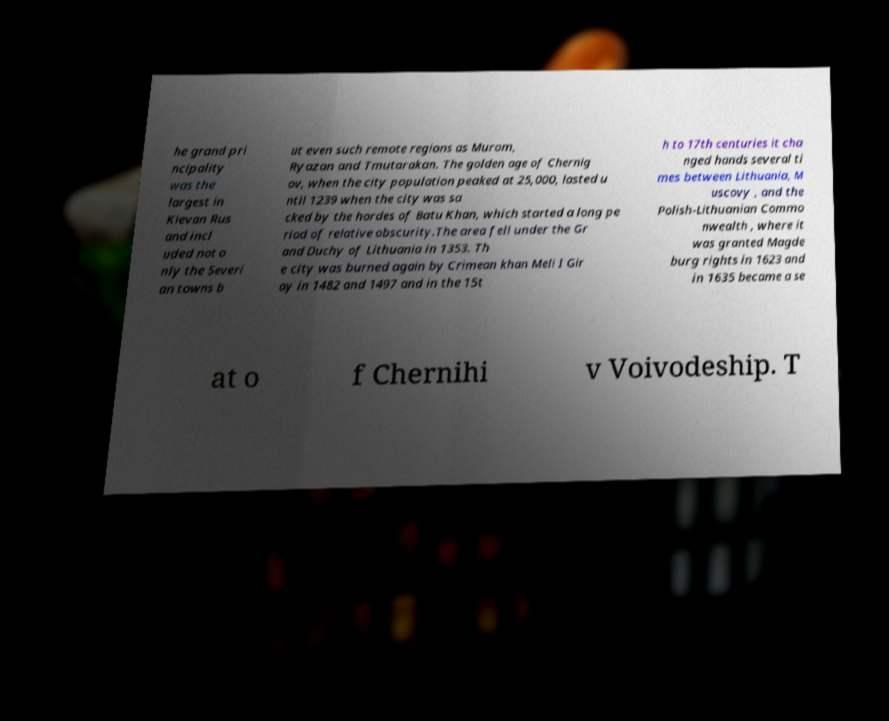Could you extract and type out the text from this image? he grand pri ncipality was the largest in Kievan Rus and incl uded not o nly the Severi an towns b ut even such remote regions as Murom, Ryazan and Tmutarakan. The golden age of Chernig ov, when the city population peaked at 25,000, lasted u ntil 1239 when the city was sa cked by the hordes of Batu Khan, which started a long pe riod of relative obscurity.The area fell under the Gr and Duchy of Lithuania in 1353. Th e city was burned again by Crimean khan Meli I Gir ay in 1482 and 1497 and in the 15t h to 17th centuries it cha nged hands several ti mes between Lithuania, M uscovy , and the Polish-Lithuanian Commo nwealth , where it was granted Magde burg rights in 1623 and in 1635 became a se at o f Chernihi v Voivodeship. T 